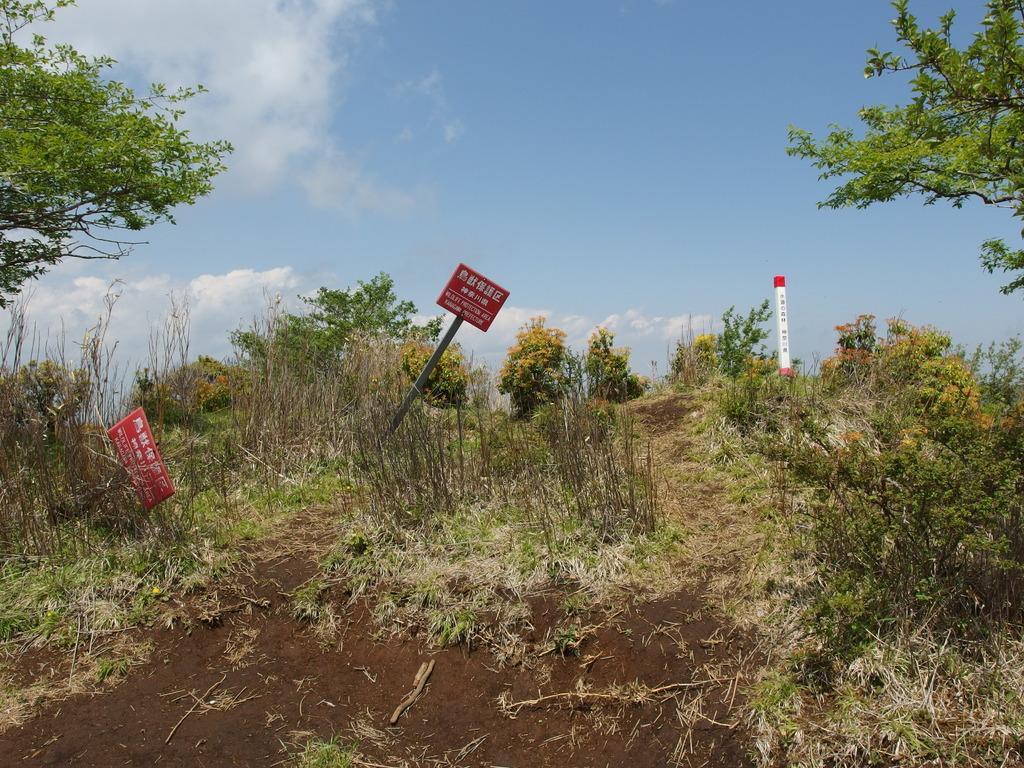Could you give a brief overview of what you see in this image? In this picture there are boards on the poles and there is text on the boards and there is text on the stone and there are trees and plants. At the top there is sky and there are clouds. At the bottom there is ground. 